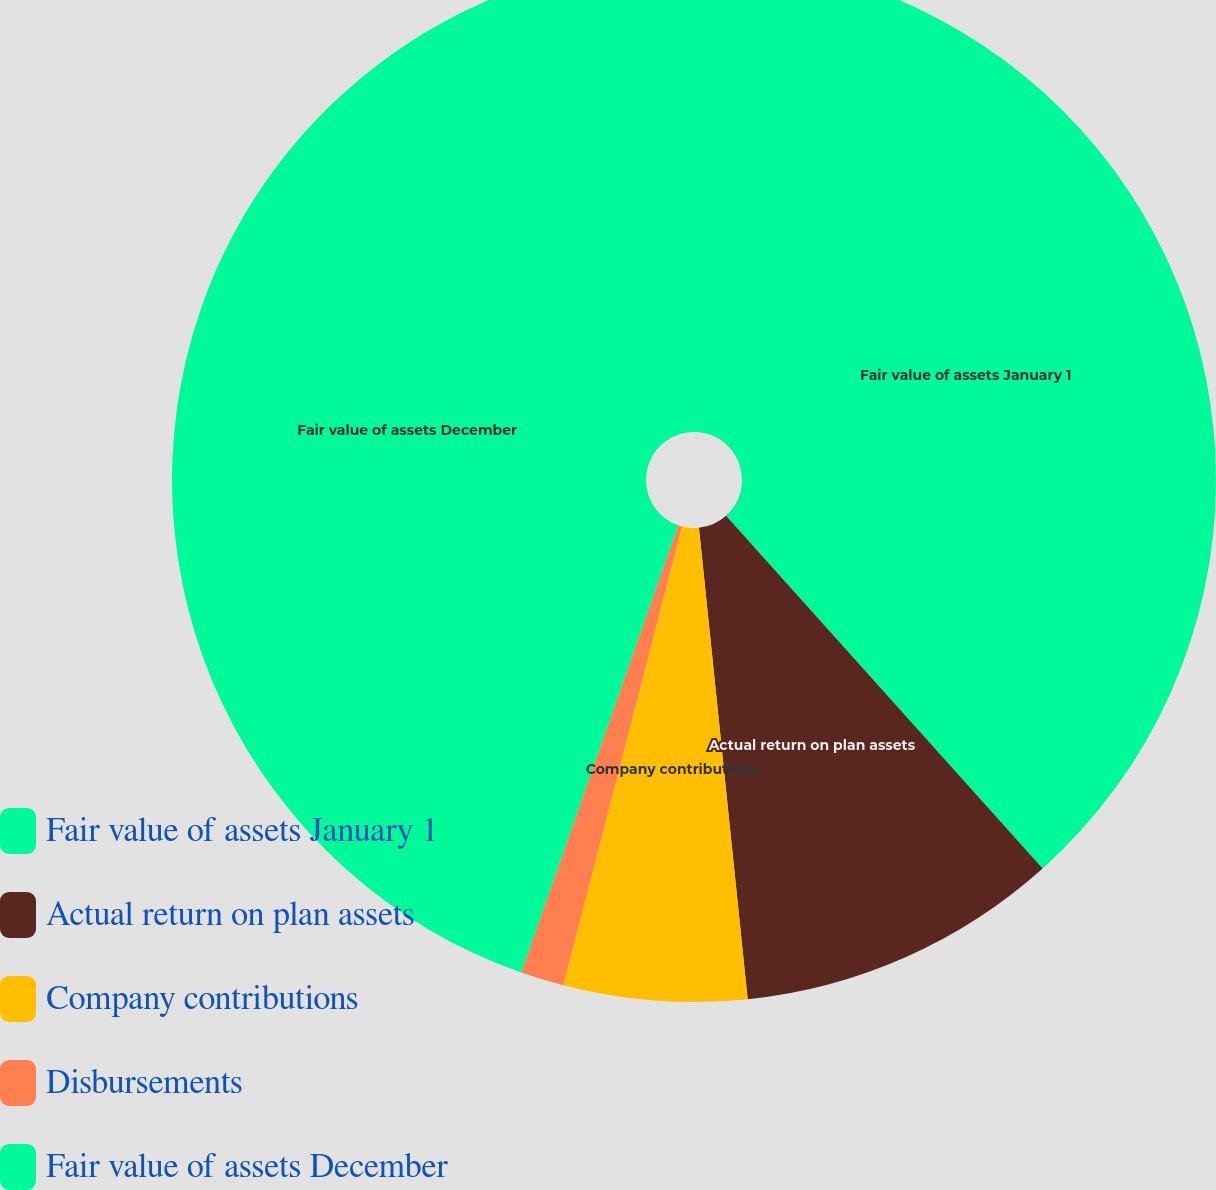Convert chart. <chart><loc_0><loc_0><loc_500><loc_500><pie_chart><fcel>Fair value of assets January 1<fcel>Actual return on plan assets<fcel>Company contributions<fcel>Disbursements<fcel>Fair value of assets December<nl><fcel>38.36%<fcel>10.0%<fcel>5.67%<fcel>1.34%<fcel>44.63%<nl></chart> 